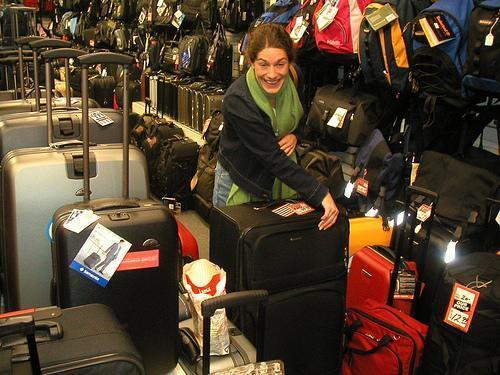How many suitcases are there?
Give a very brief answer. 11. How many backpacks are there?
Give a very brief answer. 3. How many elephants are near the rocks?
Give a very brief answer. 0. 